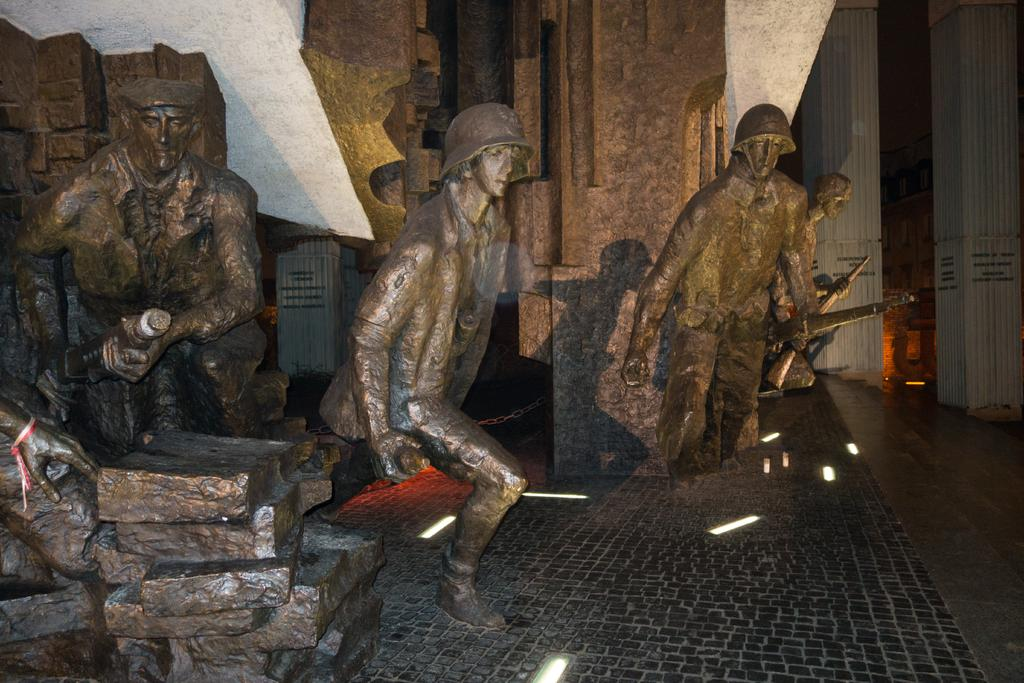What is on the floor in the image? There are person statues on the floor. What is behind the statues? There is a wall behind the statues. What are the persons holding in the image? The persons are holding guns. What are the persons wearing on their heads? The persons are wearing caps. What can be seen at the left bottom of the image? There are rocks at the left bottom of the image. What type of record is being played by the deer in the image? There is no deer or record present in the image. 